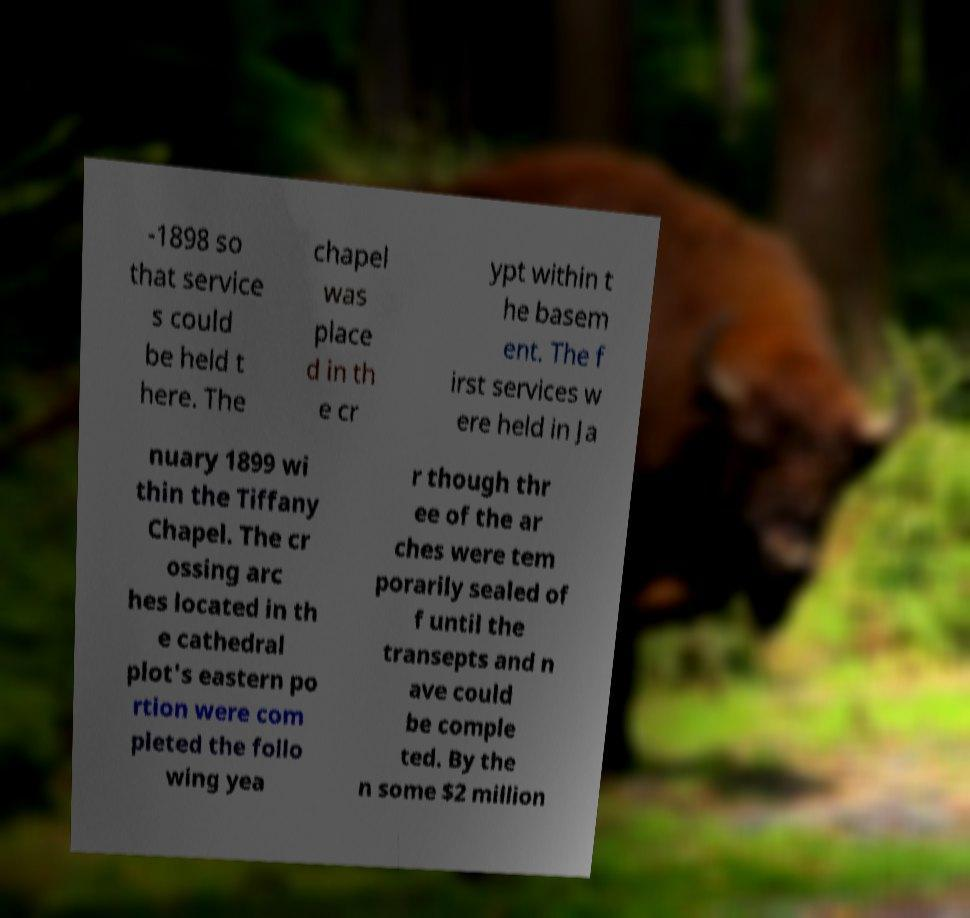Can you read and provide the text displayed in the image?This photo seems to have some interesting text. Can you extract and type it out for me? -1898 so that service s could be held t here. The chapel was place d in th e cr ypt within t he basem ent. The f irst services w ere held in Ja nuary 1899 wi thin the Tiffany Chapel. The cr ossing arc hes located in th e cathedral plot's eastern po rtion were com pleted the follo wing yea r though thr ee of the ar ches were tem porarily sealed of f until the transepts and n ave could be comple ted. By the n some $2 million 